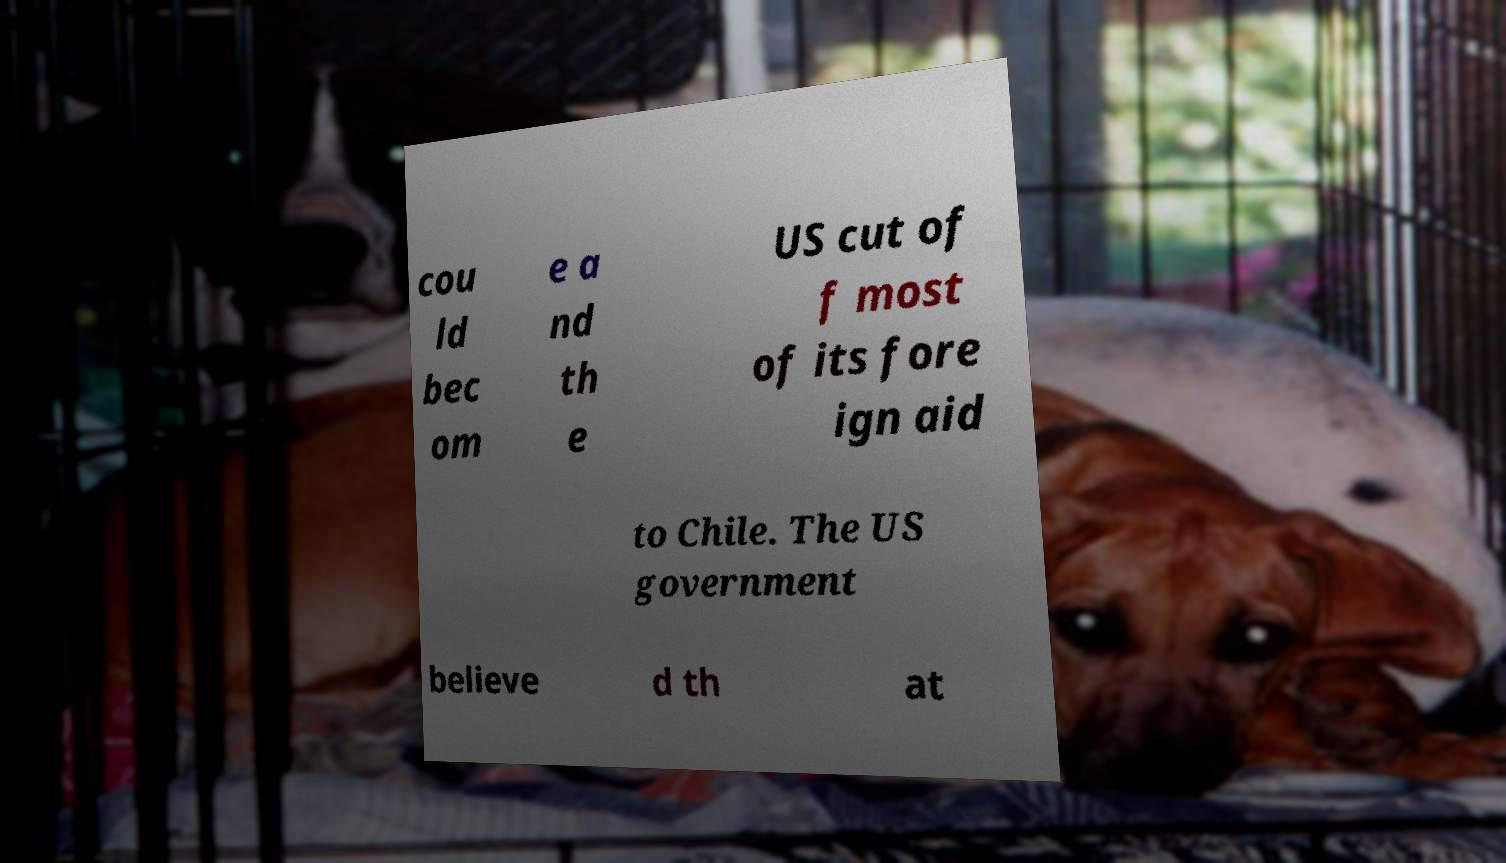Can you read and provide the text displayed in the image?This photo seems to have some interesting text. Can you extract and type it out for me? cou ld bec om e a nd th e US cut of f most of its fore ign aid to Chile. The US government believe d th at 